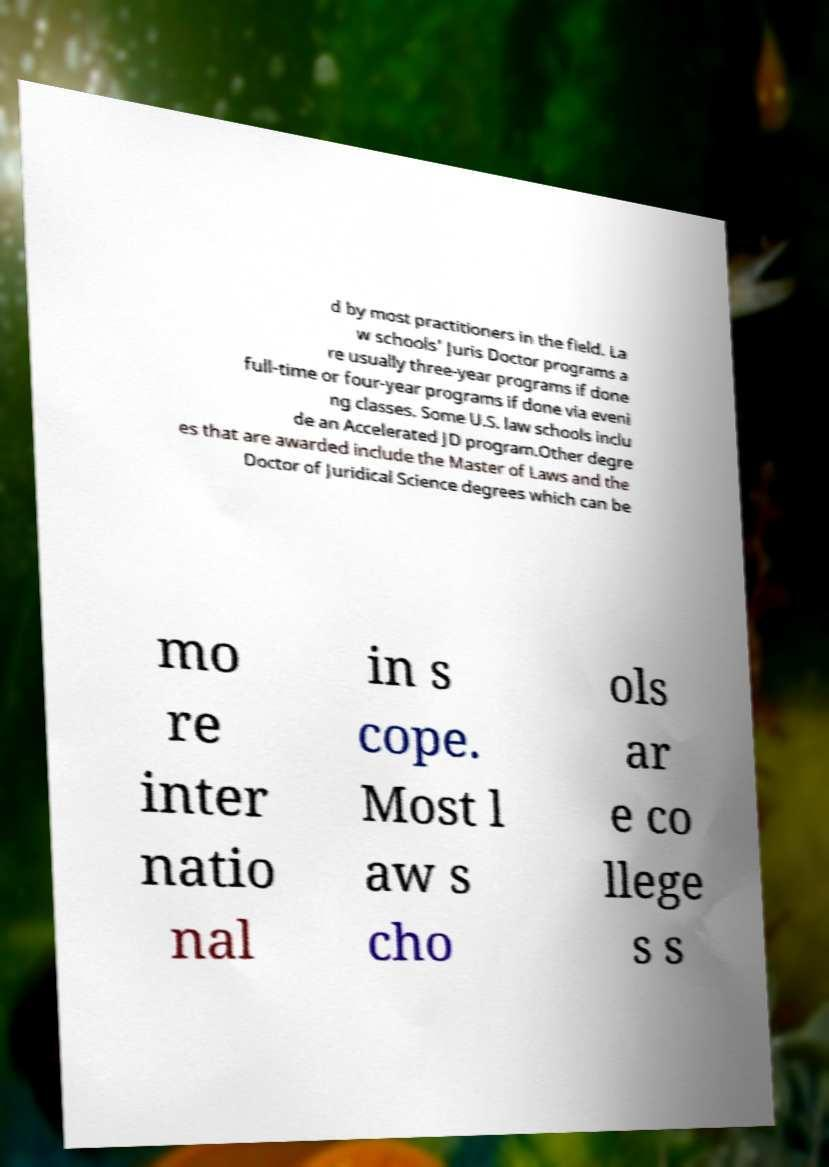Can you accurately transcribe the text from the provided image for me? d by most practitioners in the field. La w schools' Juris Doctor programs a re usually three-year programs if done full-time or four-year programs if done via eveni ng classes. Some U.S. law schools inclu de an Accelerated JD program.Other degre es that are awarded include the Master of Laws and the Doctor of Juridical Science degrees which can be mo re inter natio nal in s cope. Most l aw s cho ols ar e co llege s s 